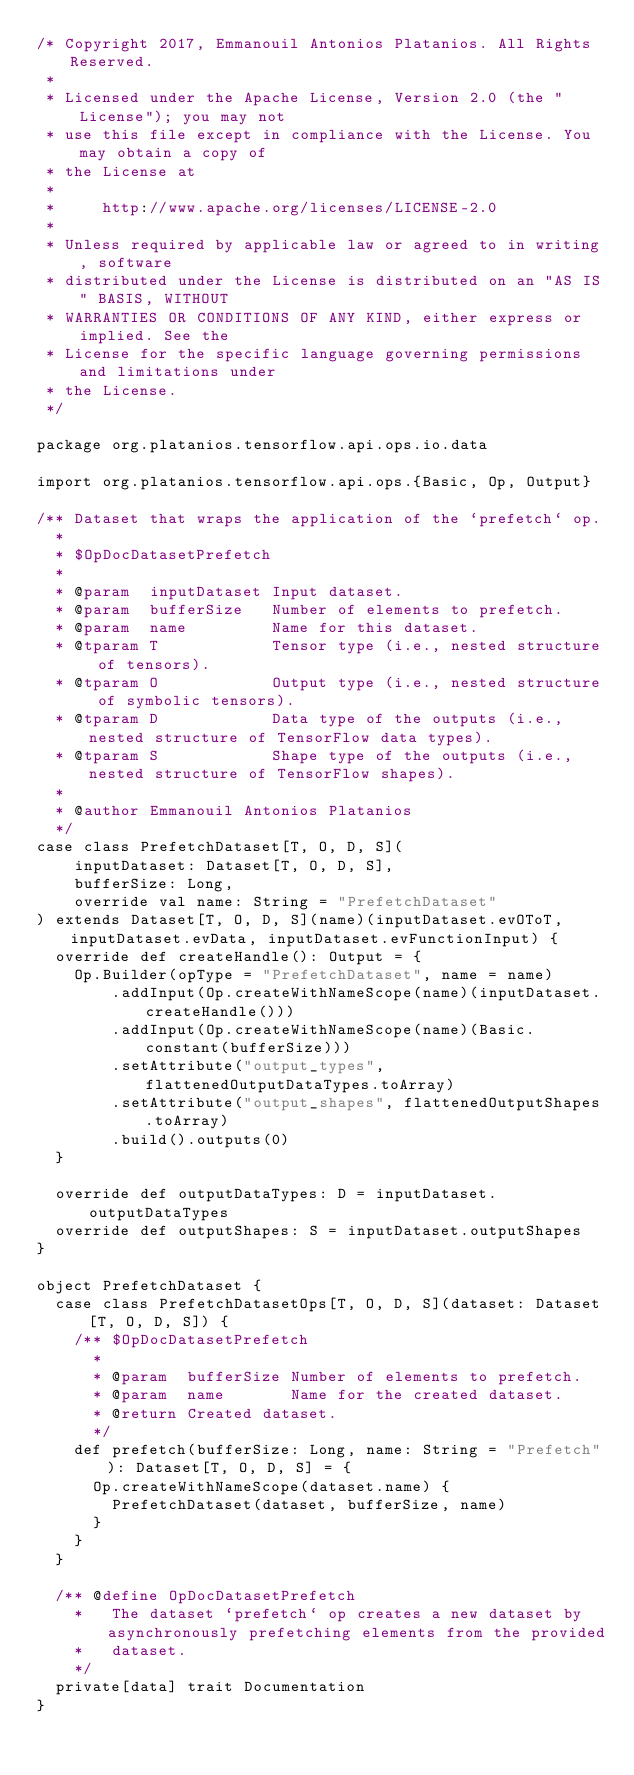<code> <loc_0><loc_0><loc_500><loc_500><_Scala_>/* Copyright 2017, Emmanouil Antonios Platanios. All Rights Reserved.
 *
 * Licensed under the Apache License, Version 2.0 (the "License"); you may not
 * use this file except in compliance with the License. You may obtain a copy of
 * the License at
 *
 *     http://www.apache.org/licenses/LICENSE-2.0
 *
 * Unless required by applicable law or agreed to in writing, software
 * distributed under the License is distributed on an "AS IS" BASIS, WITHOUT
 * WARRANTIES OR CONDITIONS OF ANY KIND, either express or implied. See the
 * License for the specific language governing permissions and limitations under
 * the License.
 */

package org.platanios.tensorflow.api.ops.io.data

import org.platanios.tensorflow.api.ops.{Basic, Op, Output}

/** Dataset that wraps the application of the `prefetch` op.
  *
  * $OpDocDatasetPrefetch
  *
  * @param  inputDataset Input dataset.
  * @param  bufferSize   Number of elements to prefetch.
  * @param  name         Name for this dataset.
  * @tparam T            Tensor type (i.e., nested structure of tensors).
  * @tparam O            Output type (i.e., nested structure of symbolic tensors).
  * @tparam D            Data type of the outputs (i.e., nested structure of TensorFlow data types).
  * @tparam S            Shape type of the outputs (i.e., nested structure of TensorFlow shapes).
  *
  * @author Emmanouil Antonios Platanios
  */
case class PrefetchDataset[T, O, D, S](
    inputDataset: Dataset[T, O, D, S],
    bufferSize: Long,
    override val name: String = "PrefetchDataset"
) extends Dataset[T, O, D, S](name)(inputDataset.evOToT, inputDataset.evData, inputDataset.evFunctionInput) {
  override def createHandle(): Output = {
    Op.Builder(opType = "PrefetchDataset", name = name)
        .addInput(Op.createWithNameScope(name)(inputDataset.createHandle()))
        .addInput(Op.createWithNameScope(name)(Basic.constant(bufferSize)))
        .setAttribute("output_types", flattenedOutputDataTypes.toArray)
        .setAttribute("output_shapes", flattenedOutputShapes.toArray)
        .build().outputs(0)
  }

  override def outputDataTypes: D = inputDataset.outputDataTypes
  override def outputShapes: S = inputDataset.outputShapes
}

object PrefetchDataset {
  case class PrefetchDatasetOps[T, O, D, S](dataset: Dataset[T, O, D, S]) {
    /** $OpDocDatasetPrefetch
      *
      * @param  bufferSize Number of elements to prefetch.
      * @param  name       Name for the created dataset.
      * @return Created dataset.
      */
    def prefetch(bufferSize: Long, name: String = "Prefetch"): Dataset[T, O, D, S] = {
      Op.createWithNameScope(dataset.name) {
        PrefetchDataset(dataset, bufferSize, name)
      }
    }
  }

  /** @define OpDocDatasetPrefetch
    *   The dataset `prefetch` op creates a new dataset by asynchronously prefetching elements from the provided
    *   dataset.
    */
  private[data] trait Documentation
}
</code> 